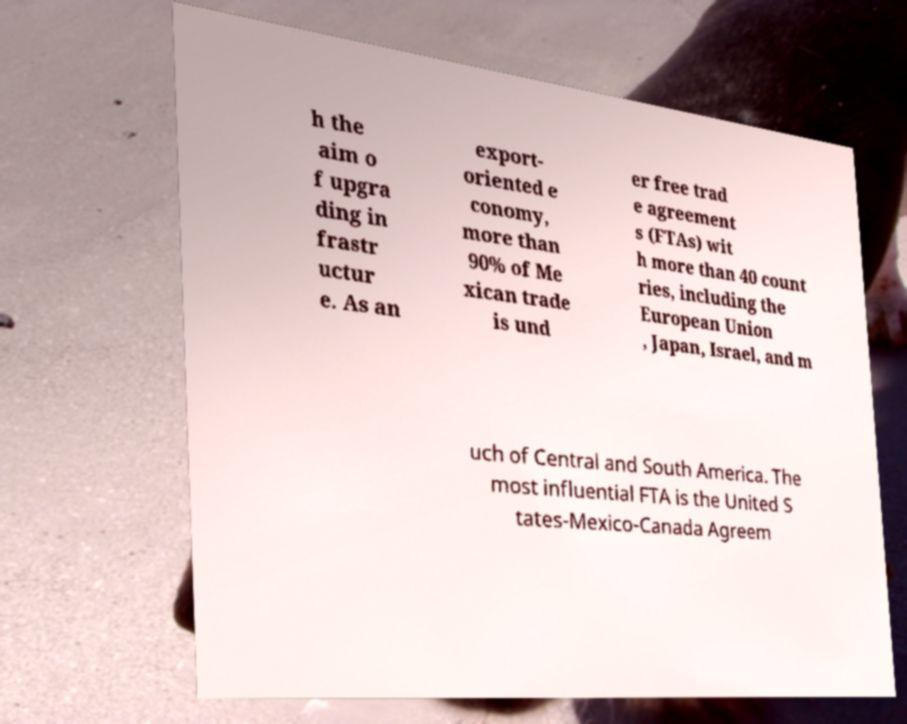Could you assist in decoding the text presented in this image and type it out clearly? h the aim o f upgra ding in frastr uctur e. As an export- oriented e conomy, more than 90% of Me xican trade is und er free trad e agreement s (FTAs) wit h more than 40 count ries, including the European Union , Japan, Israel, and m uch of Central and South America. The most influential FTA is the United S tates-Mexico-Canada Agreem 